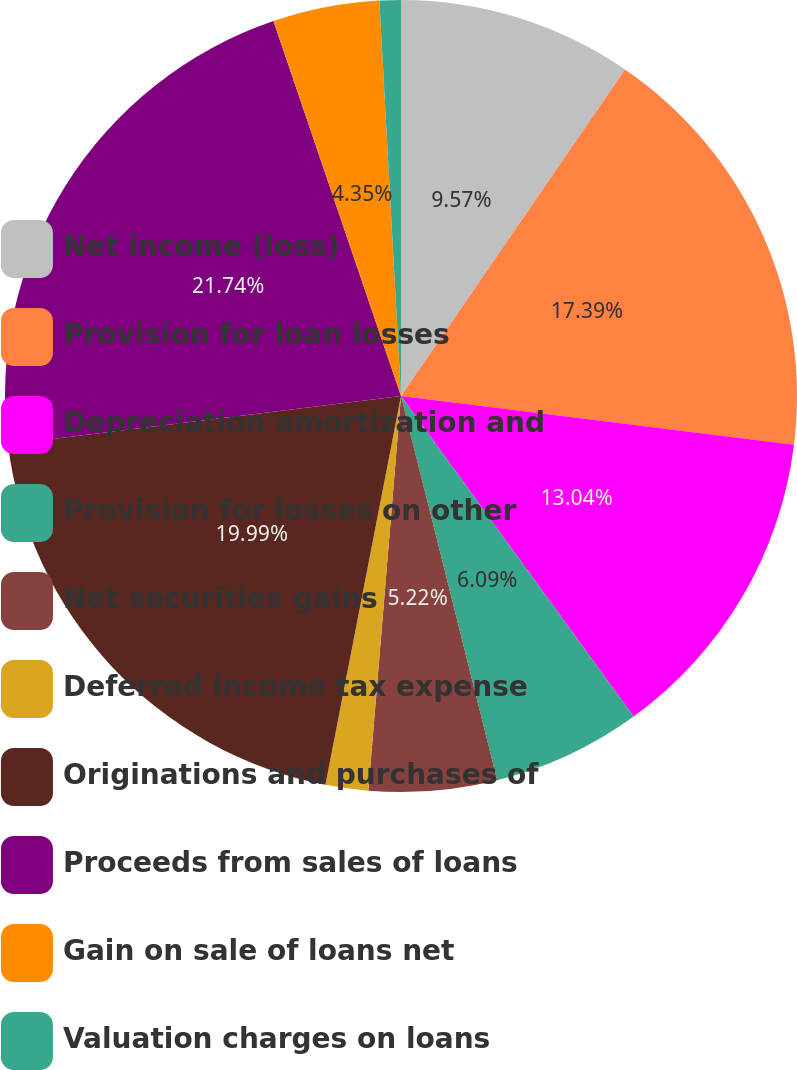Convert chart to OTSL. <chart><loc_0><loc_0><loc_500><loc_500><pie_chart><fcel>Net income (loss)<fcel>Provision for loan losses<fcel>Depreciation amortization and<fcel>Provision for losses on other<fcel>Net securities gains<fcel>Deferred income tax expense<fcel>Originations and purchases of<fcel>Proceeds from sales of loans<fcel>Gain on sale of loans net<fcel>Valuation charges on loans<nl><fcel>9.57%<fcel>17.39%<fcel>13.04%<fcel>6.09%<fcel>5.22%<fcel>1.74%<fcel>19.99%<fcel>21.73%<fcel>4.35%<fcel>0.87%<nl></chart> 